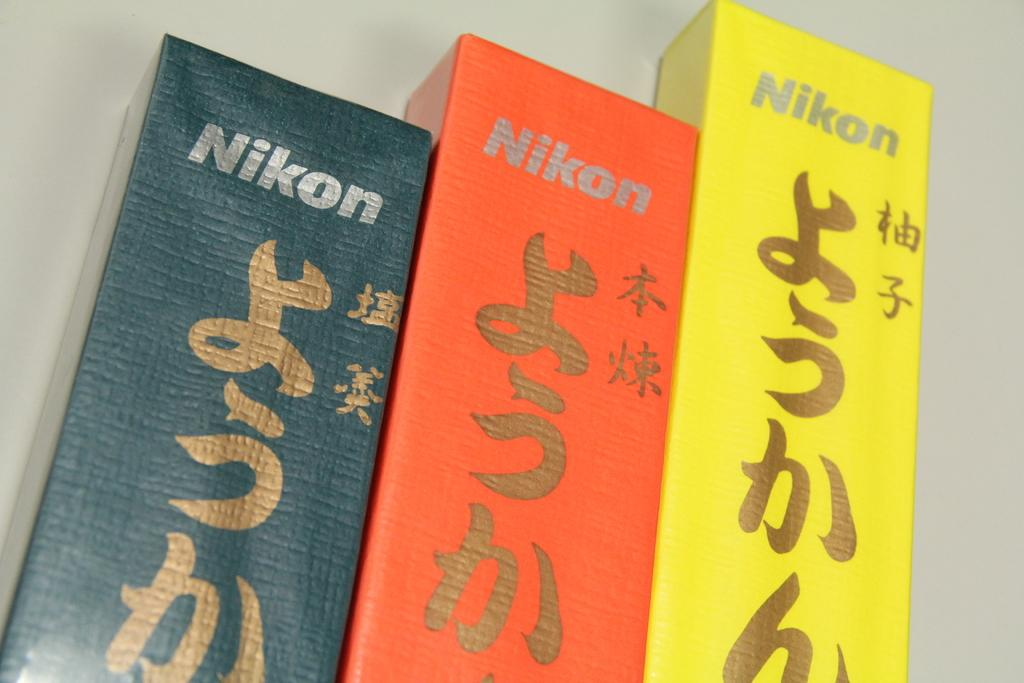<image>
Provide a brief description of the given image. A set of three books with Nikon on them. 